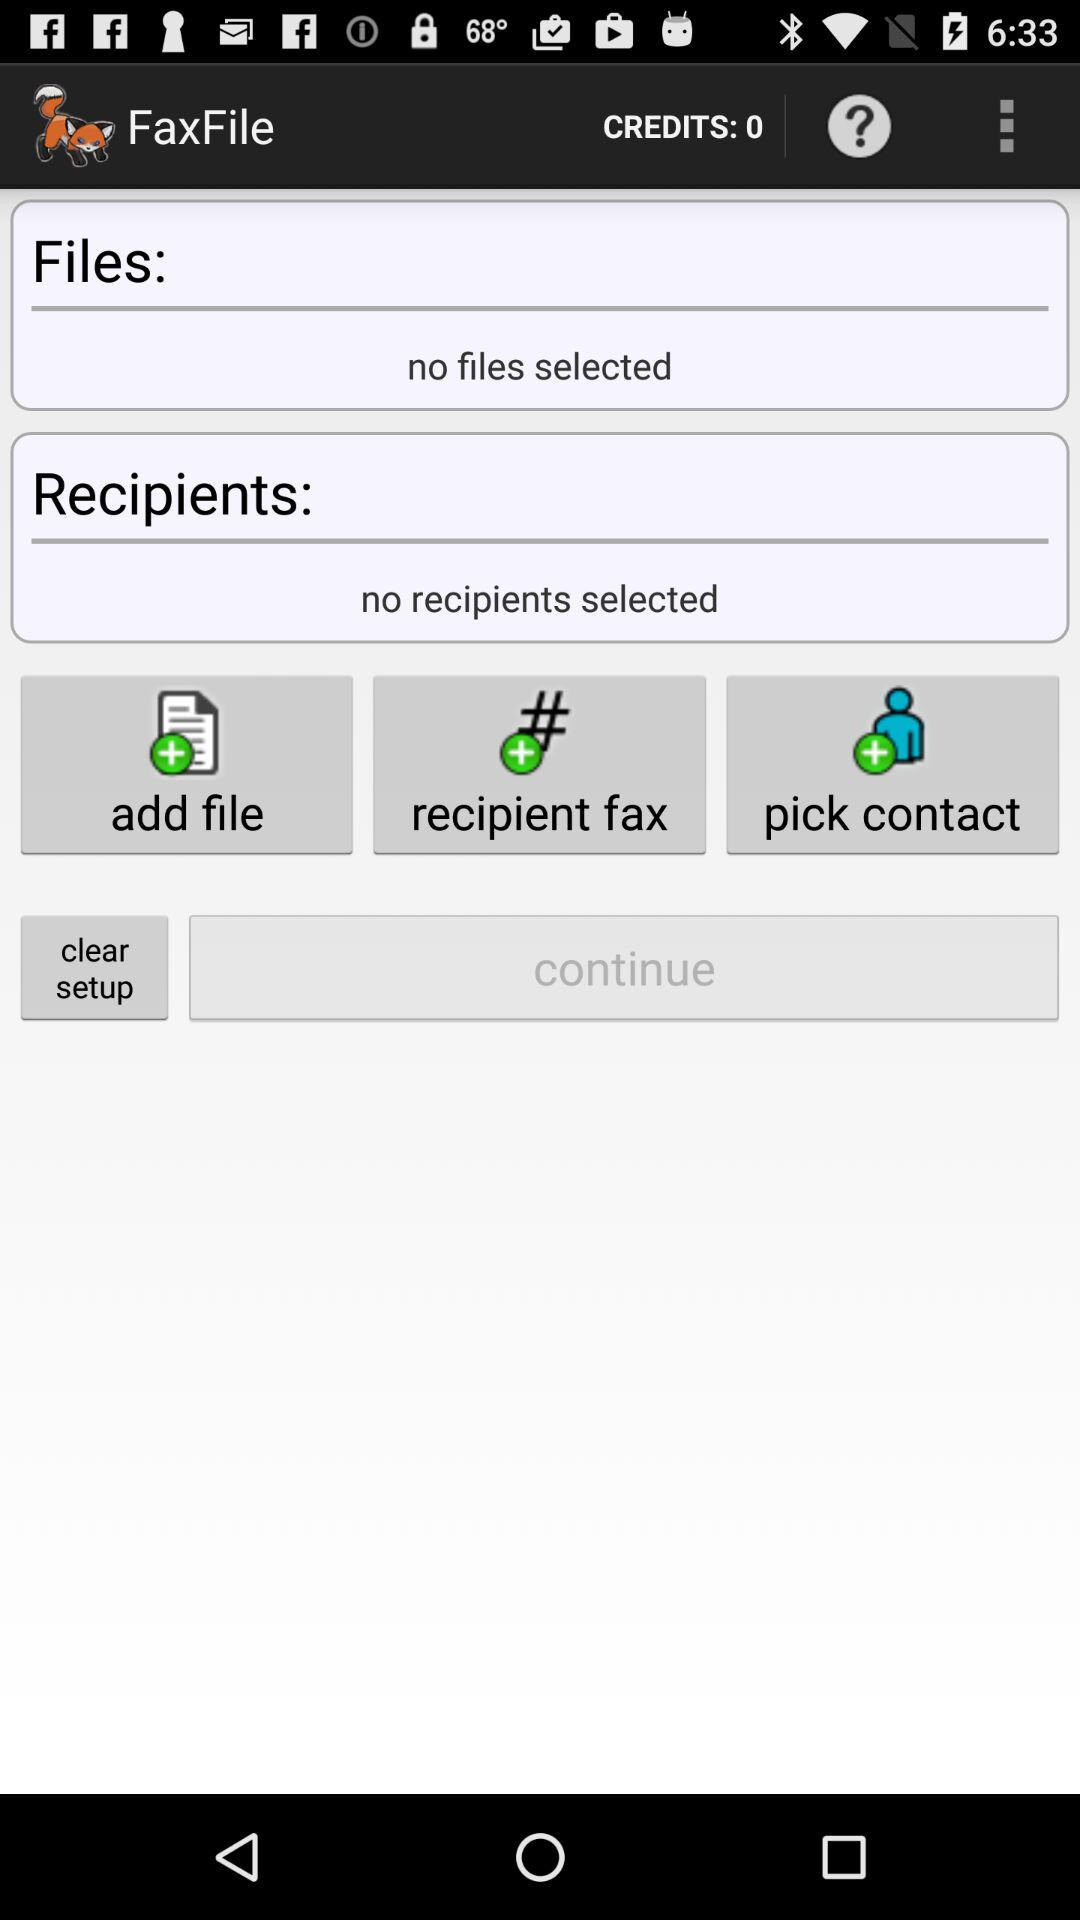How many credits are there? There are 0 credits. 